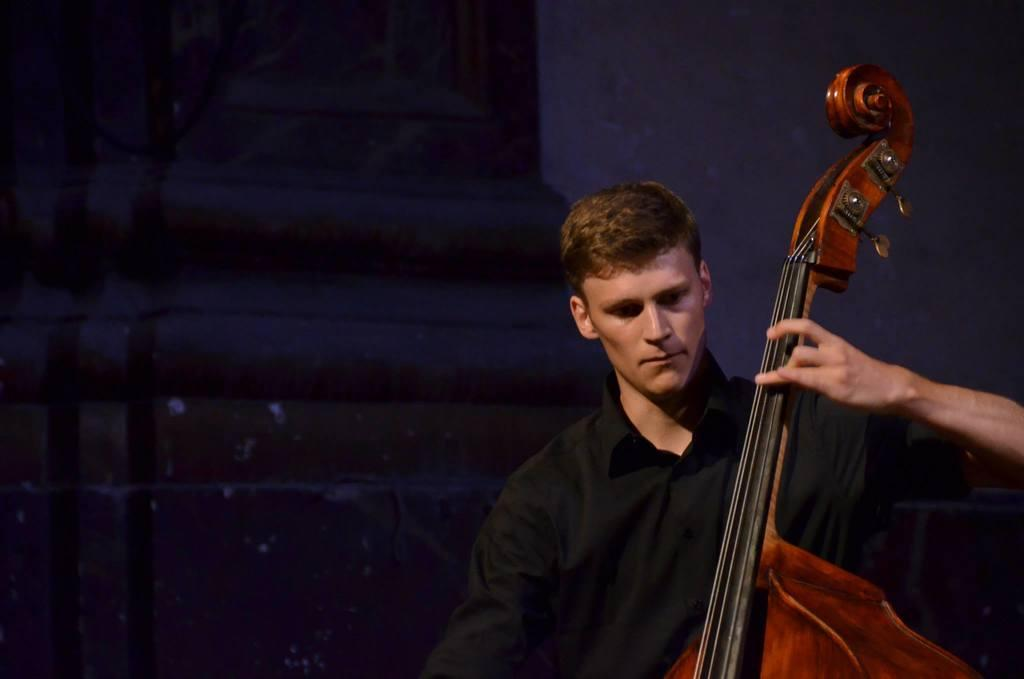What is the main activity being performed by a person in the image? There is a person playing a musical instrument in the image. Can you describe the attire of one of the persons in the image? There is a person wearing a black color dress in the image. What type of alarm is being used by the person wearing the black dress in the image? There is no alarm present in the image; it features a person playing a musical instrument and another person wearing a black dress. 